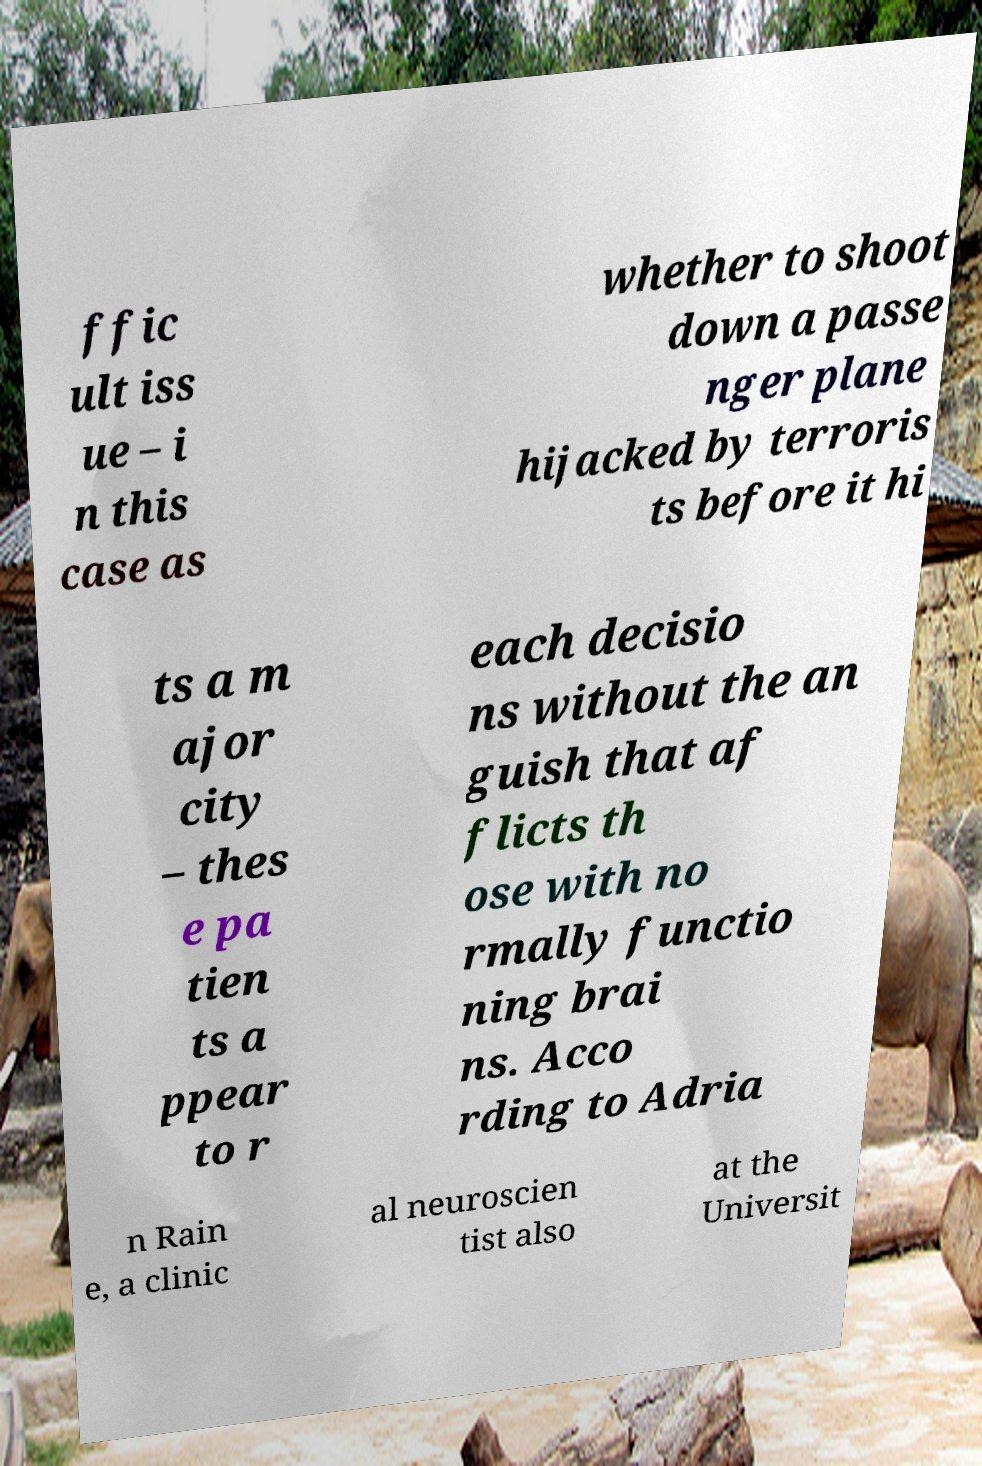Can you read and provide the text displayed in the image?This photo seems to have some interesting text. Can you extract and type it out for me? ffic ult iss ue – i n this case as whether to shoot down a passe nger plane hijacked by terroris ts before it hi ts a m ajor city – thes e pa tien ts a ppear to r each decisio ns without the an guish that af flicts th ose with no rmally functio ning brai ns. Acco rding to Adria n Rain e, a clinic al neuroscien tist also at the Universit 